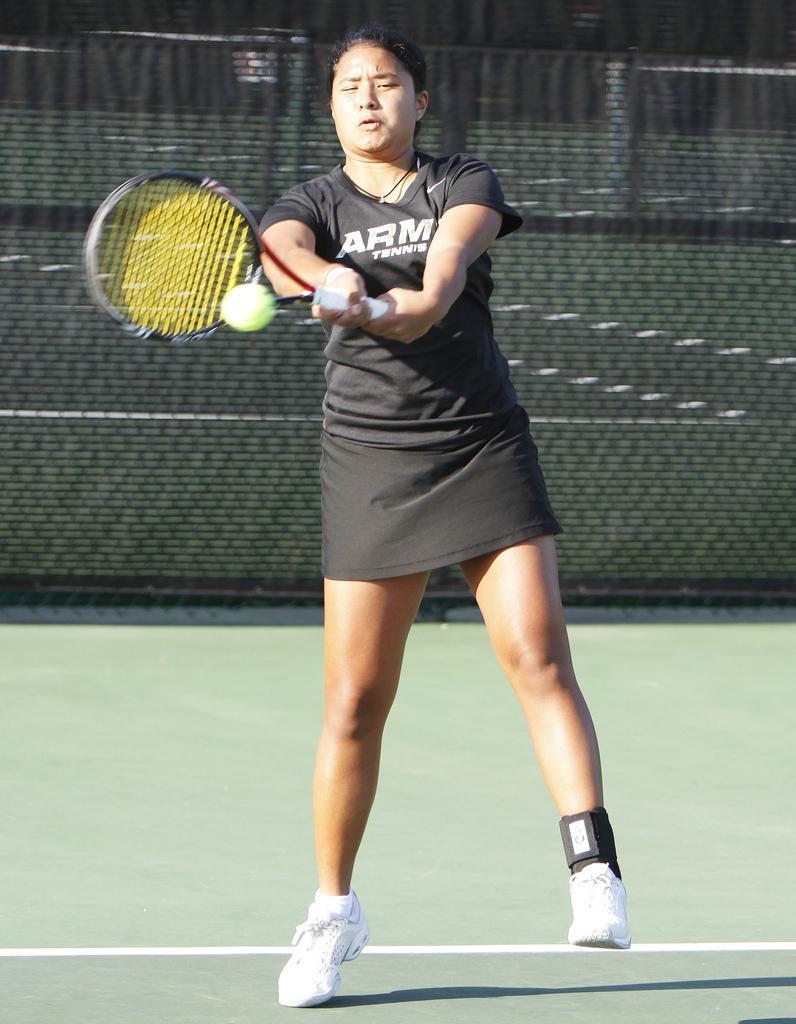Can you describe this image briefly? In this image we can see a woman is standing. She is wearing black color dress and holding racket in her hand. In front of the racket ball is present. Background of the image black color fencing is present. Bottom of the image green color floor is there. 